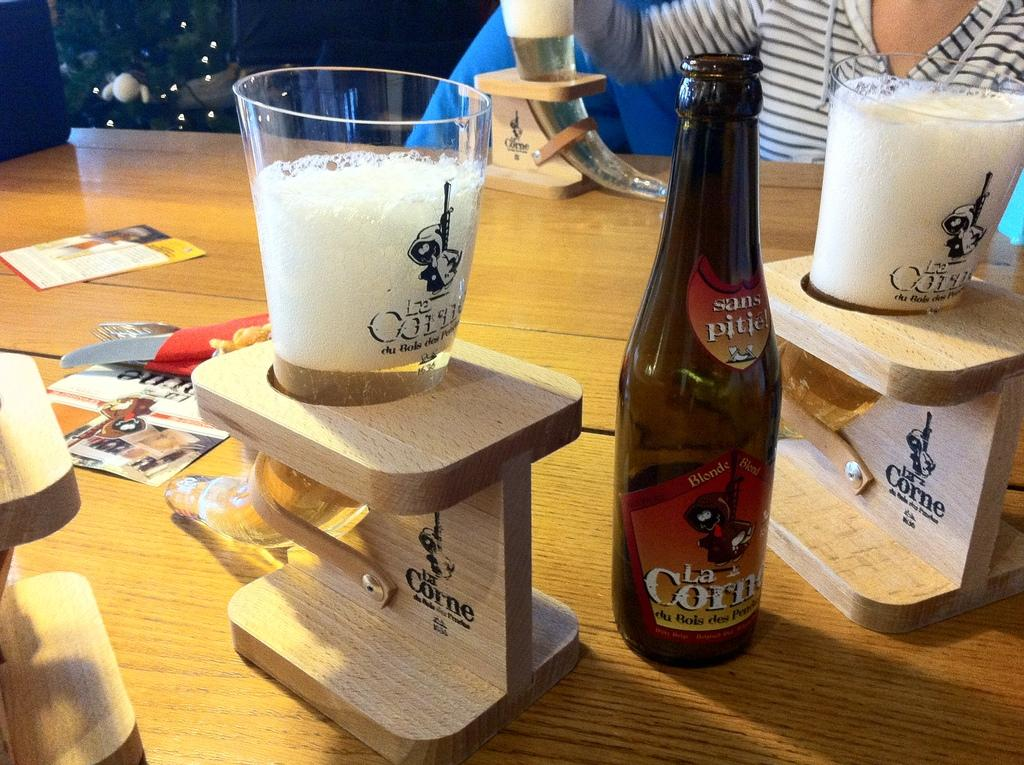<image>
Create a compact narrative representing the image presented. A bottle of La Corn beer next to two La Corn Glass drinking horns. 